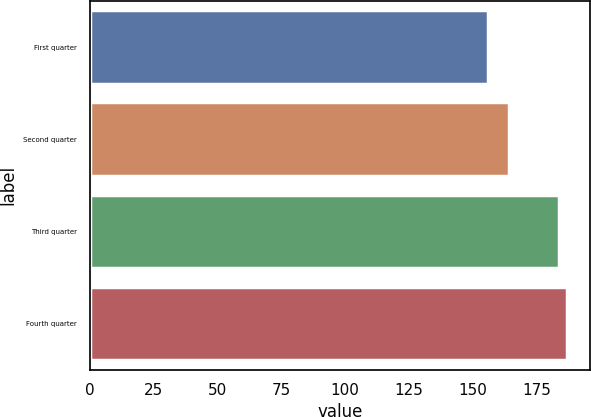Convert chart. <chart><loc_0><loc_0><loc_500><loc_500><bar_chart><fcel>First quarter<fcel>Second quarter<fcel>Third quarter<fcel>Fourth quarter<nl><fcel>156.09<fcel>164.25<fcel>183.86<fcel>186.85<nl></chart> 